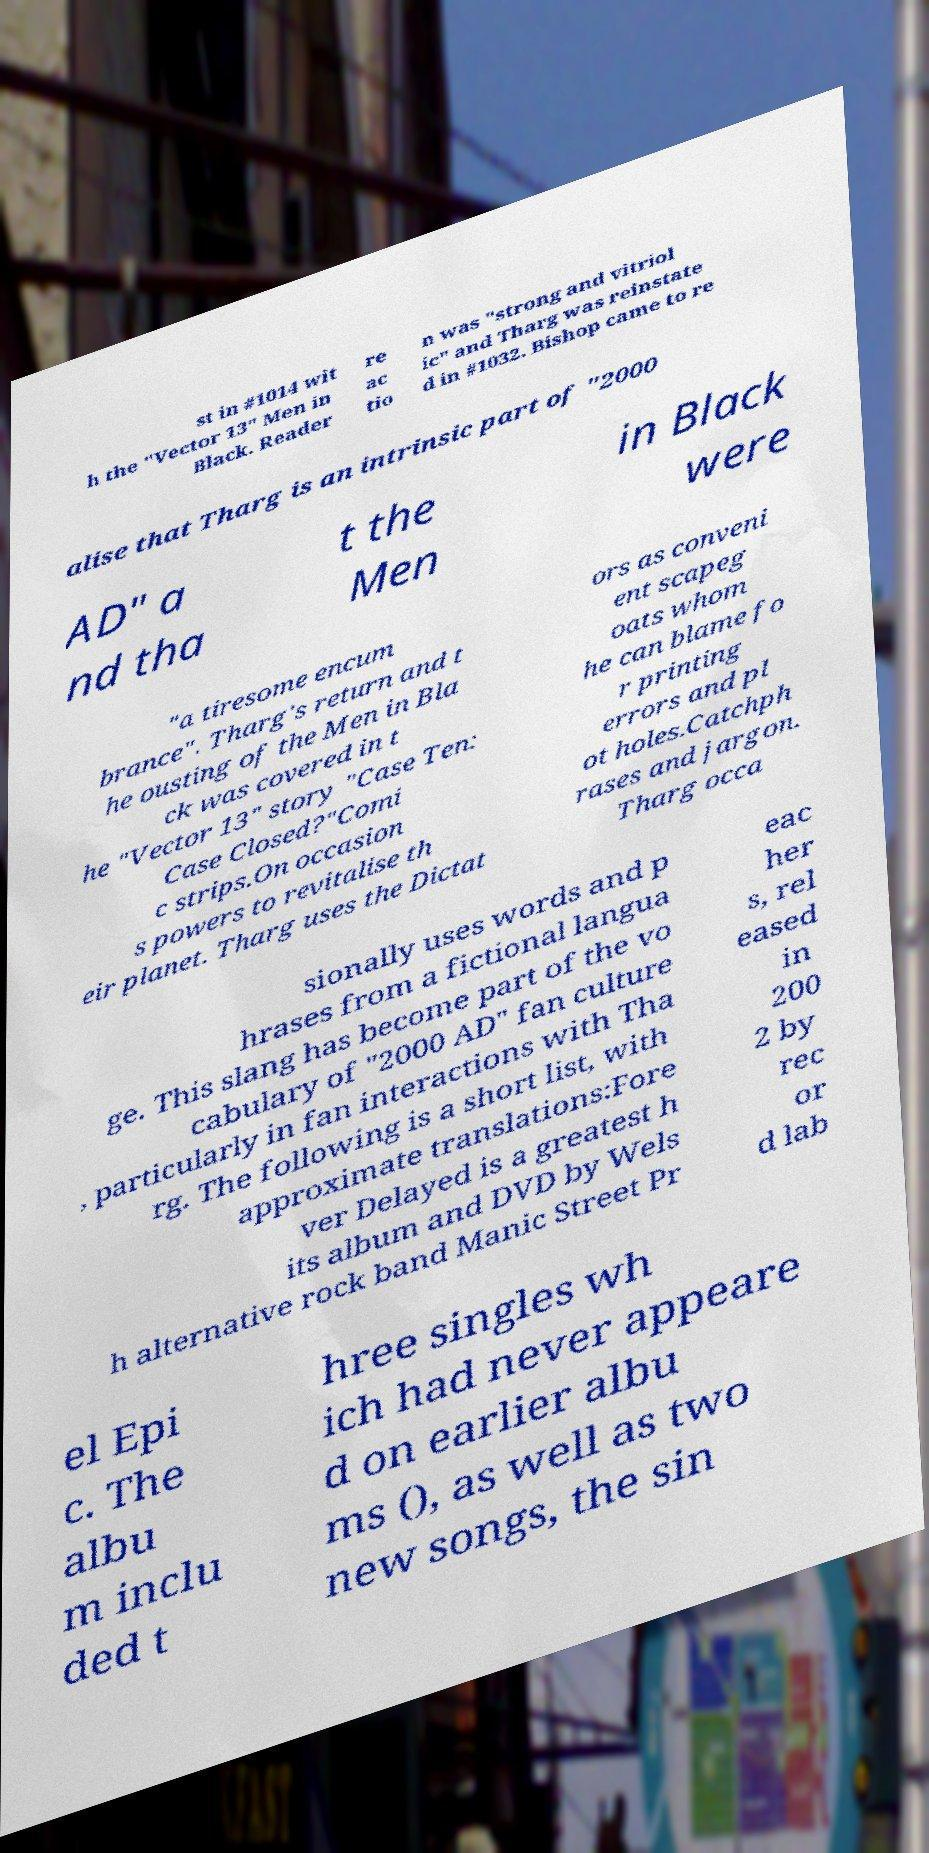Could you assist in decoding the text presented in this image and type it out clearly? st in #1014 wit h the "Vector 13" Men in Black. Reader re ac tio n was "strong and vitriol ic" and Tharg was reinstate d in #1032. Bishop came to re alise that Tharg is an intrinsic part of "2000 AD" a nd tha t the Men in Black were "a tiresome encum brance". Tharg's return and t he ousting of the Men in Bla ck was covered in t he "Vector 13" story "Case Ten: Case Closed?"Comi c strips.On occasion s powers to revitalise th eir planet. Tharg uses the Dictat ors as conveni ent scapeg oats whom he can blame fo r printing errors and pl ot holes.Catchph rases and jargon. Tharg occa sionally uses words and p hrases from a fictional langua ge. This slang has become part of the vo cabulary of "2000 AD" fan culture , particularly in fan interactions with Tha rg. The following is a short list, with approximate translations:Fore ver Delayed is a greatest h its album and DVD by Wels h alternative rock band Manic Street Pr eac her s, rel eased in 200 2 by rec or d lab el Epi c. The albu m inclu ded t hree singles wh ich had never appeare d on earlier albu ms (), as well as two new songs, the sin 